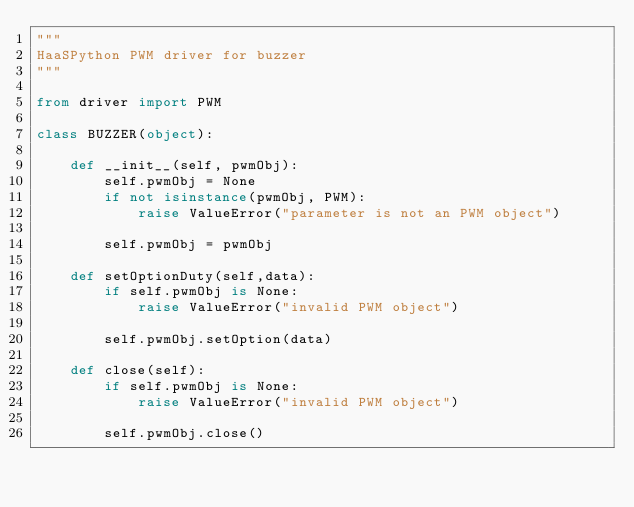<code> <loc_0><loc_0><loc_500><loc_500><_Python_>"""
HaaSPython PWM driver for buzzer
"""

from driver import PWM

class BUZZER(object):

    def __init__(self, pwmObj):
        self.pwmObj = None
        if not isinstance(pwmObj, PWM):
            raise ValueError("parameter is not an PWM object")

        self.pwmObj = pwmObj

    def setOptionDuty(self,data):
        if self.pwmObj is None:
            raise ValueError("invalid PWM object")

        self.pwmObj.setOption(data)

    def close(self):
        if self.pwmObj is None:
            raise ValueError("invalid PWM object")

        self.pwmObj.close()
</code> 